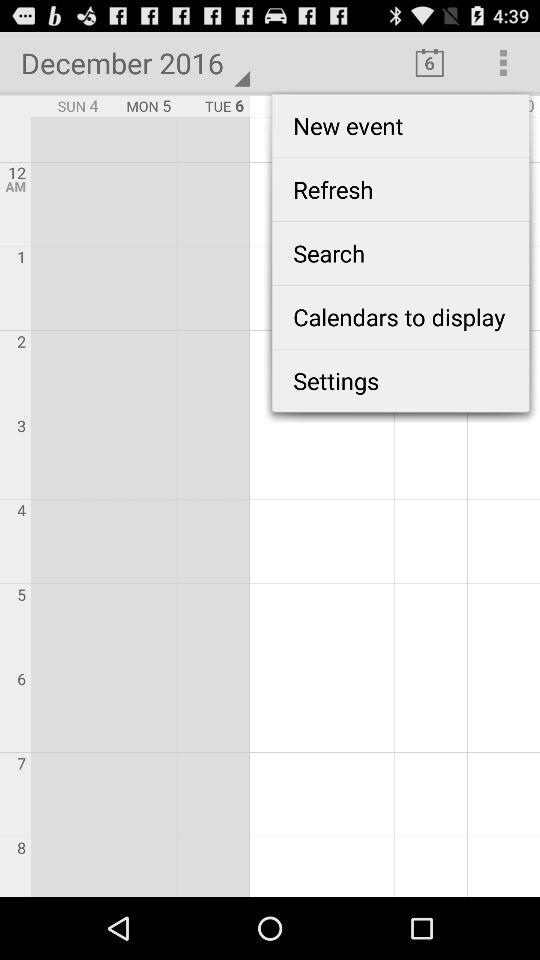What is the year? The year is 2016. 